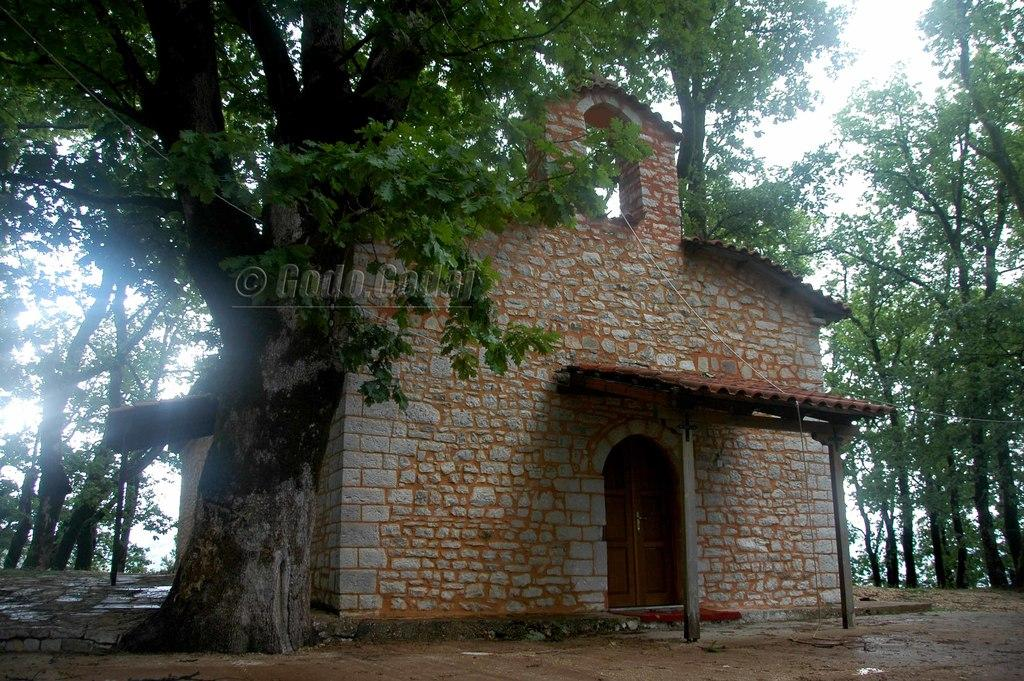What type of house is in the image? There is a stone house in the image. What other natural elements can be seen in the image? There are trees in the image. What object is present in the image that is not a part of the house or trees? There is a board in the image. What can be seen in the background of the image? The sky is visible in the background of the image. What type of hat is the stone house wearing in the image? There is no hat present in the image, as the main subject is a stone house. 